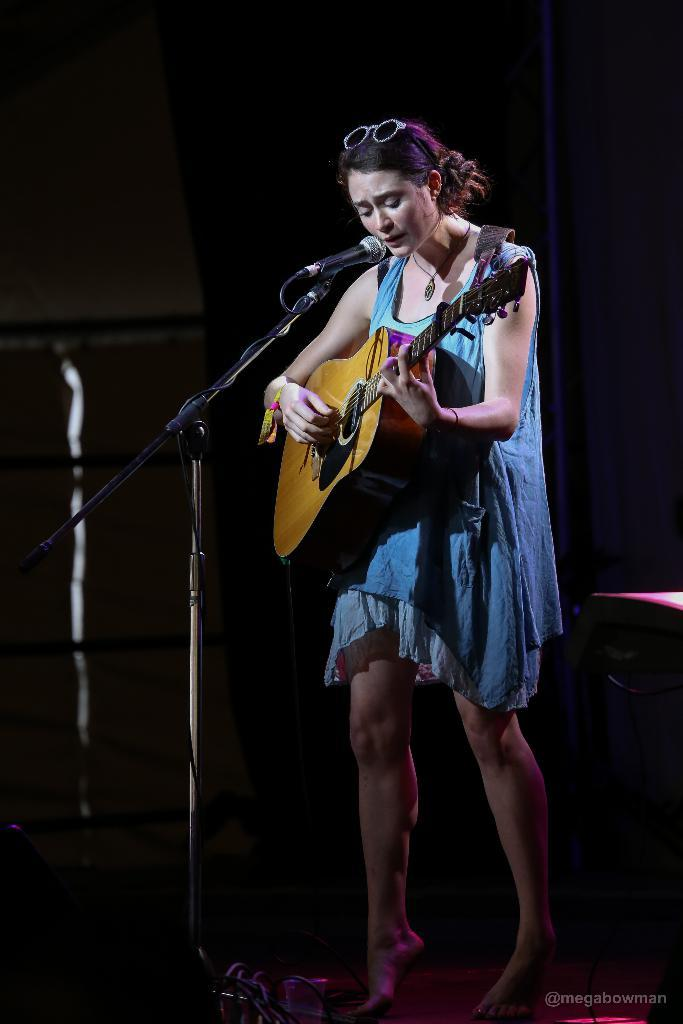What is the main subject of the image? The main subject of the image is a woman. What is the woman doing in the image? The woman is standing, playing a guitar, and singing into a microphone. What can be observed about the background of the image? The background of the image is dark. What type of beds can be seen in the image? There are no beds present in the image. What is the cause of the woman's singing in the image? The image does not provide information about the cause of the woman's singing; it only shows her singing into a microphone. 